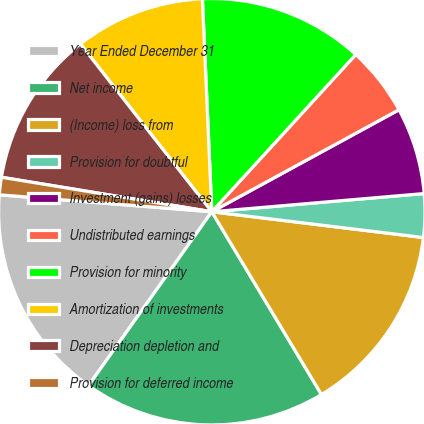Convert chart to OTSL. <chart><loc_0><loc_0><loc_500><loc_500><pie_chart><fcel>Year Ended December 31<fcel>Net income<fcel>(Income) loss from<fcel>Provision for doubtful<fcel>Investment (gains) losses<fcel>Undistributed earnings<fcel>Provision for minority<fcel>Amortization of investments<fcel>Depreciation depletion and<fcel>Provision for deferred income<nl><fcel>16.45%<fcel>18.42%<fcel>14.47%<fcel>3.29%<fcel>6.58%<fcel>5.26%<fcel>12.5%<fcel>9.87%<fcel>11.84%<fcel>1.32%<nl></chart> 